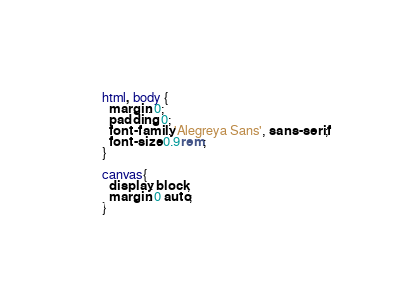Convert code to text. <code><loc_0><loc_0><loc_500><loc_500><_CSS_>html, body {
  margin: 0;
  padding: 0;
  font-family: 'Alegreya Sans', sans-serif;
  font-size: 0.9rem;
}

canvas{
  display: block;
  margin: 0 auto;
}</code> 